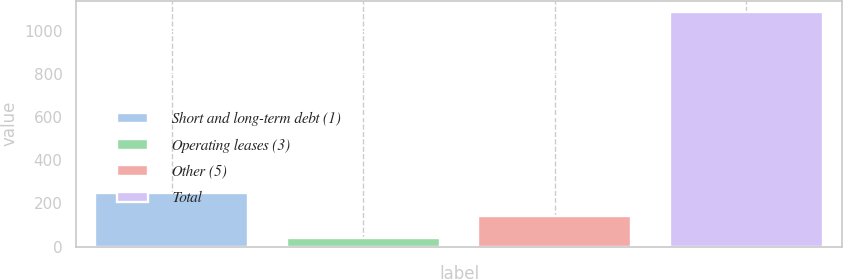Convert chart to OTSL. <chart><loc_0><loc_0><loc_500><loc_500><bar_chart><fcel>Short and long-term debt (1)<fcel>Operating leases (3)<fcel>Other (5)<fcel>Total<nl><fcel>247.36<fcel>38.1<fcel>142.73<fcel>1084.4<nl></chart> 